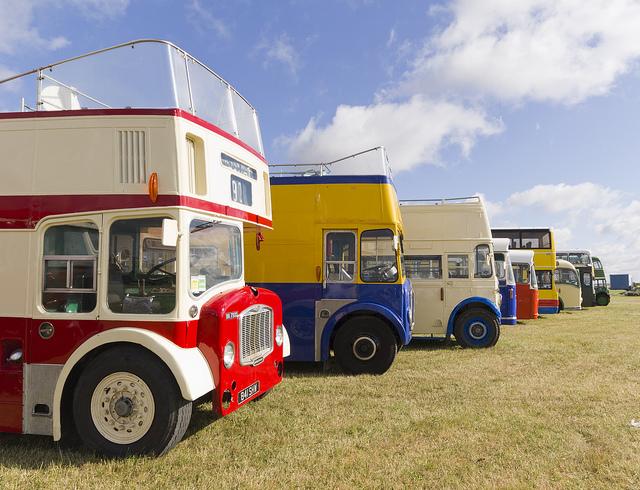Are these modern buses?
Answer briefly. No. Are these food trucks?
Write a very short answer. No. Was the photo taken in the daytime?
Write a very short answer. Yes. 